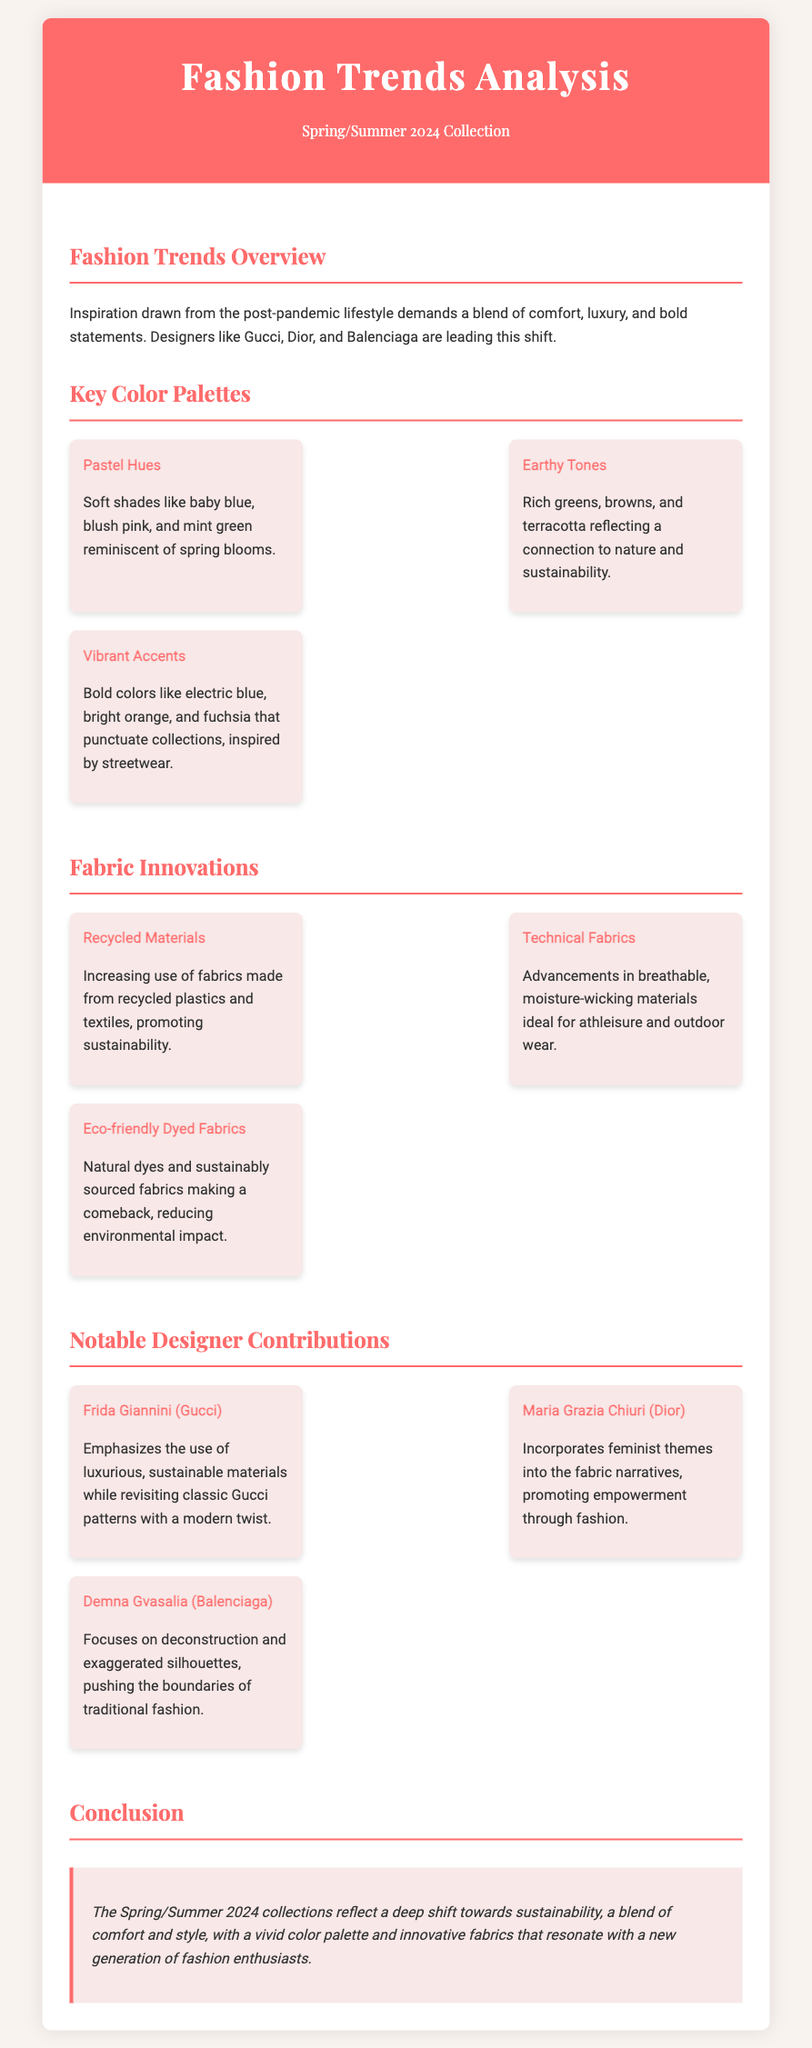What is the title of the document? The title of the document is stated clearly in the header, which is "Fashion Trends Analysis".
Answer: Fashion Trends Analysis What season and year does the collection pertain to? The document refers to the Spring/Summer collection for the year 2024.
Answer: Spring/Summer 2024 Name a color palette mentioned in the document. The document lists three color palettes, one of which is "Pastel Hues".
Answer: Pastel Hues What type of materials is emphasized in the fabric innovations? The fabric innovations include a focus on "Recycled Materials" to promote sustainability.
Answer: Recycled Materials Who is the designer associated with Gucci? The document mentions "Frida Giannini" as the designer associated with Gucci.
Answer: Frida Giannini What trend is emphasized in the fashion overview? The fashion overview highlights a trend towards "comfort, luxury, and bold statements".
Answer: Comfort, luxury, and bold statements How many fabric innovations are listed in the document? The document details a total of three fabric innovations.
Answer: Three Which designer integrates feminist themes into their work? The document mentions "Maria Grazia Chiuri" of Dior as integrating feminist themes.
Answer: Maria Grazia Chiuri What is a notable conclusion drawn in the document? The conclusion emphasizes a shift towards "sustainability" in fashion collections.
Answer: Sustainability 